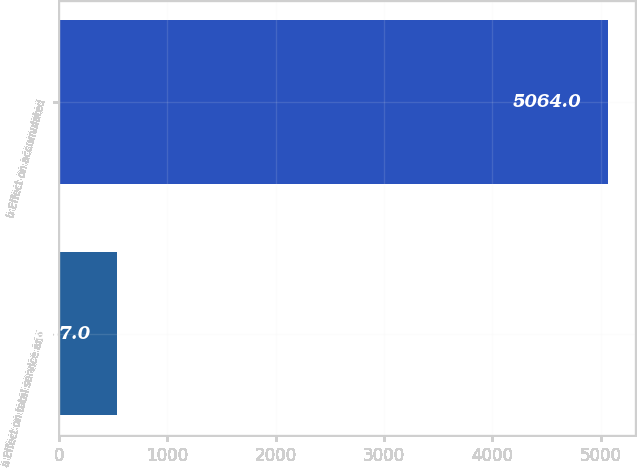<chart> <loc_0><loc_0><loc_500><loc_500><bar_chart><fcel>a Effect on total service and<fcel>b Effect on accumulated<nl><fcel>537<fcel>5064<nl></chart> 